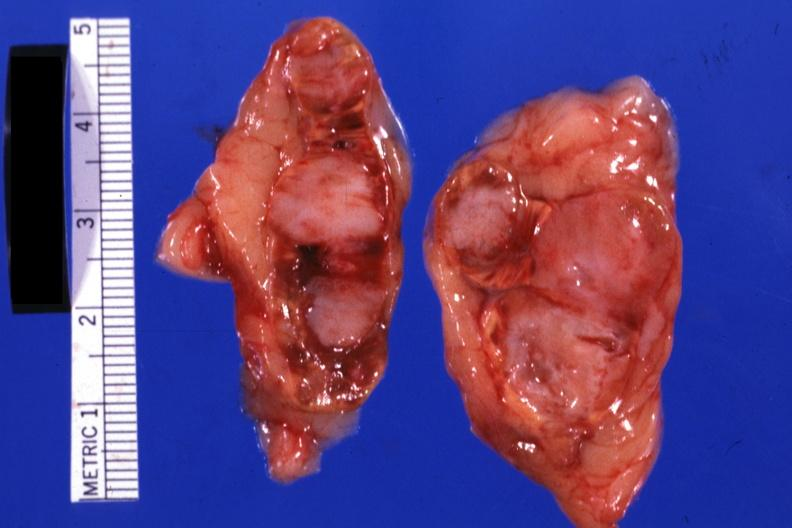s endocrine present?
Answer the question using a single word or phrase. Yes 